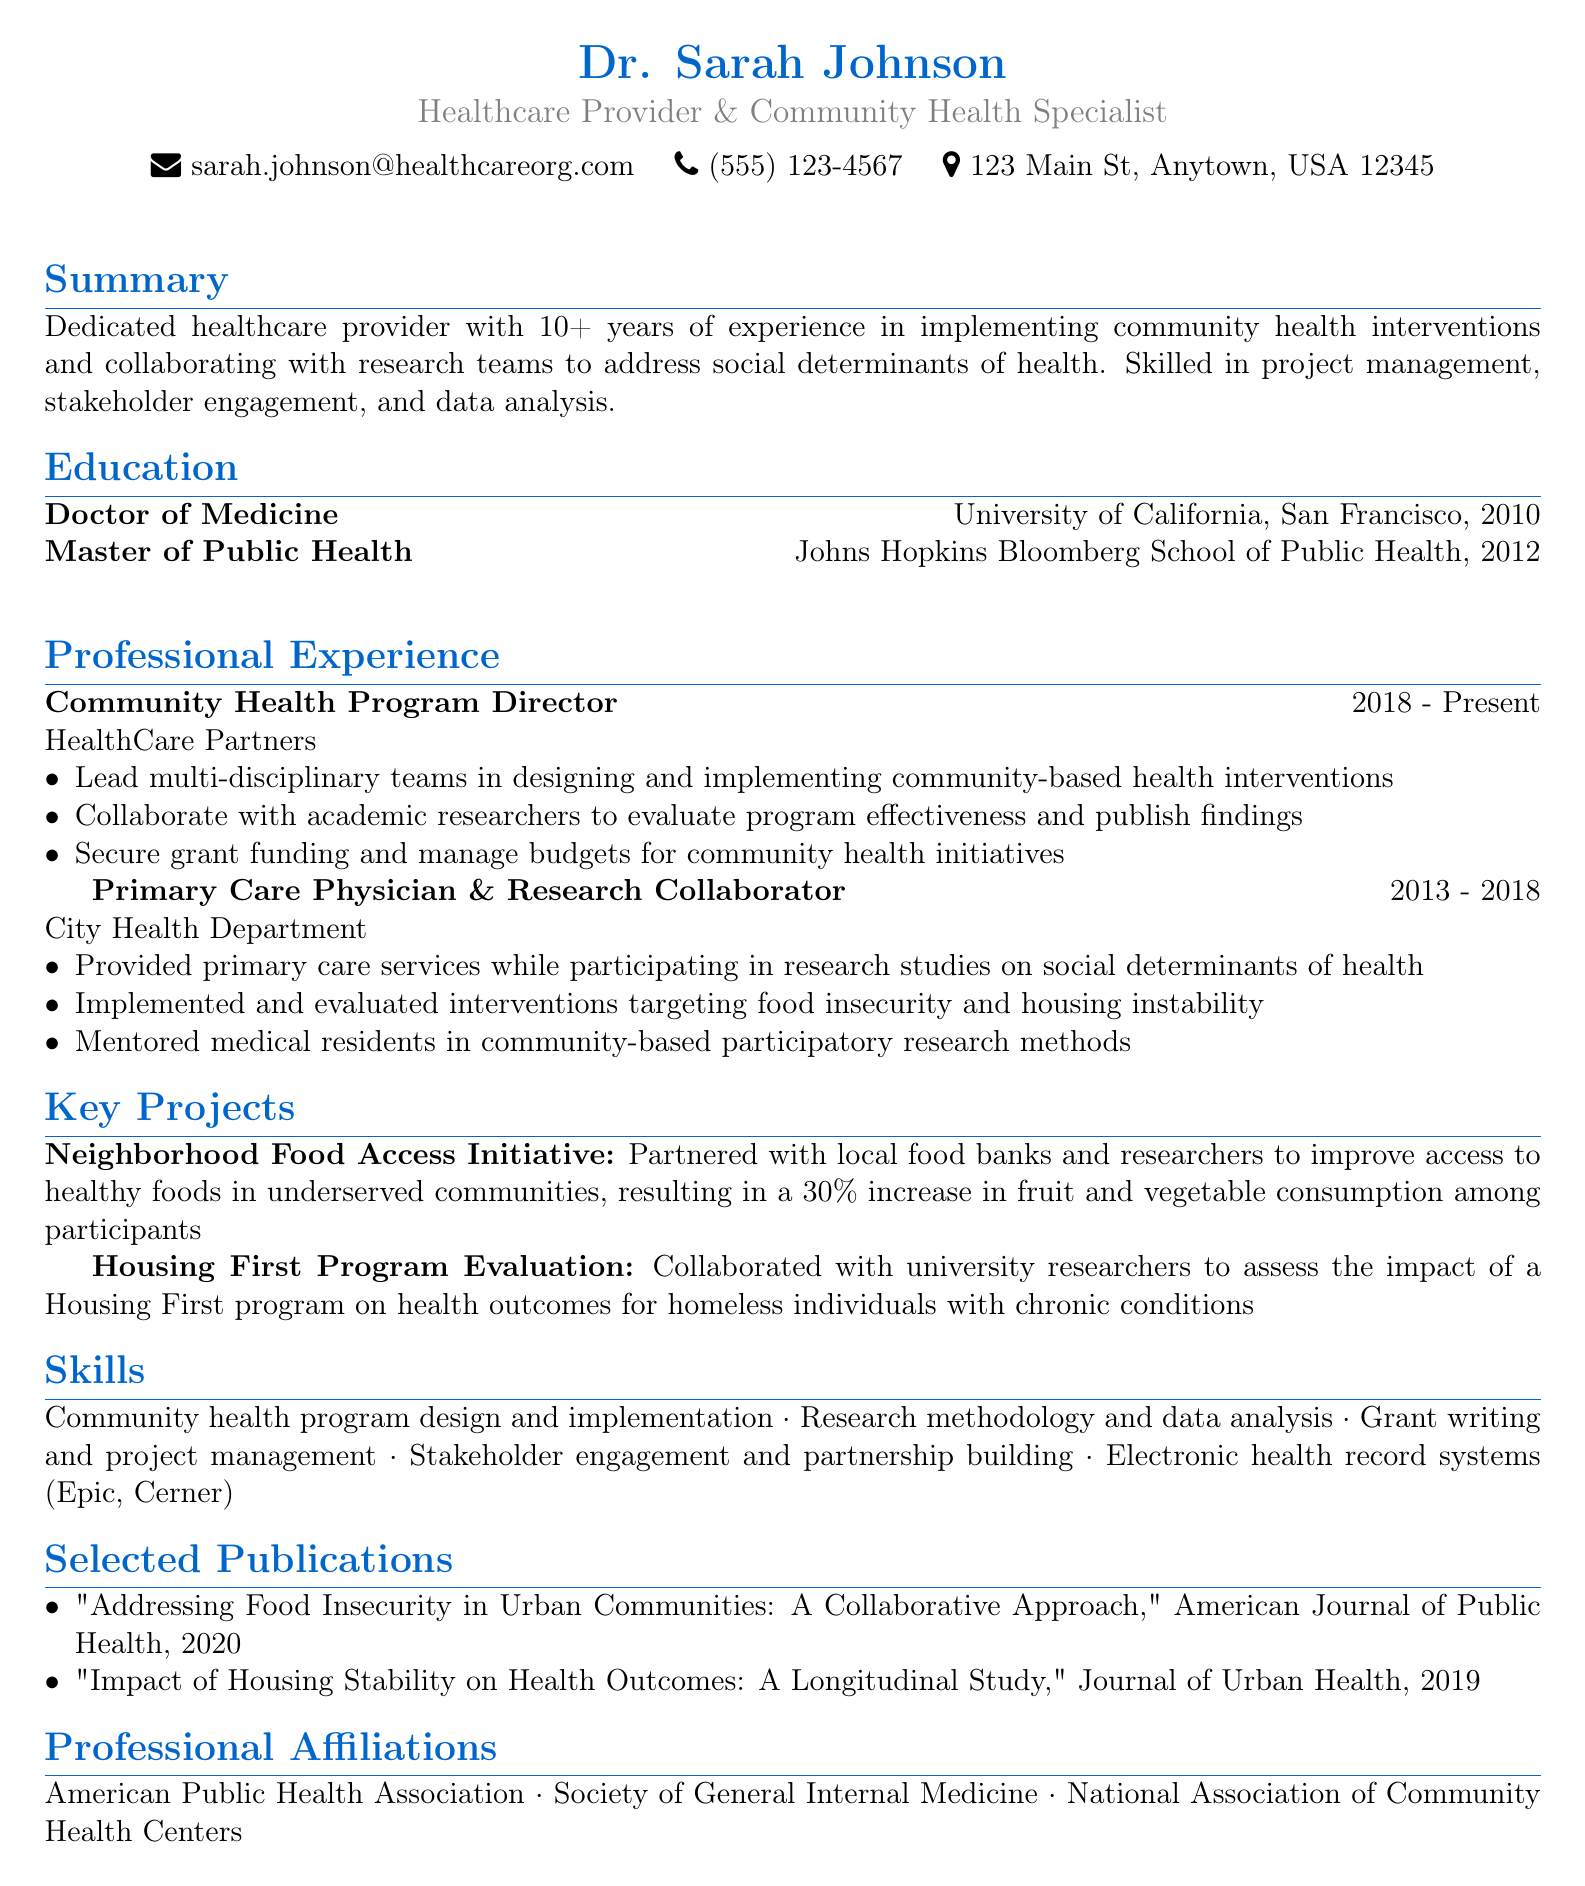what is the name of the healthcare provider? The name of the healthcare provider is stated at the top of the document.
Answer: Dr. Sarah Johnson what is the current position held by Dr. Sarah Johnson? The position is listed under the Professional Experience section.
Answer: Community Health Program Director what year did Dr. Sarah Johnson obtain her Doctor of Medicine degree? The year is found in the Education section beside the degree.
Answer: 2010 how many years of experience does Dr. Sarah Johnson have in community health interventions? This information is provided in the summary section of the document.
Answer: 10+ which initiative resulted in a 30% increase in fruit and vegetable consumption? The initiative’s name is detailed under the Key Projects section.
Answer: Neighborhood Food Access Initiative which journal published Dr. Sarah Johnson's 2020 article? The journal name is mentioned in the Selected Publications section.
Answer: American Journal of Public Health how many professional affiliations does Dr. Sarah Johnson have? The total number of affiliations can be counted in the Professional Affiliations section.
Answer: 3 what key skill is related to stakeholder engagement? The key skill mentioned in the Skills section addresses stakeholder engagement.
Answer: Stakeholder engagement and partnership building in which city is Dr. Sarah Johnson's office located? The city is specified in the contact information section of the document.
Answer: Anytown 